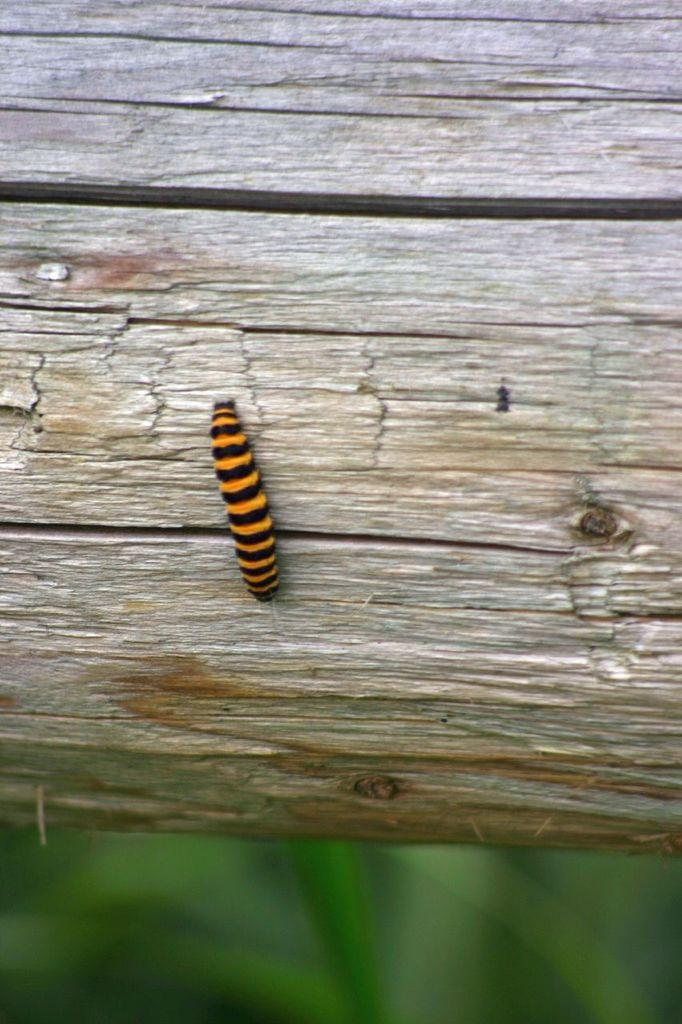Who is the main subject in the image? There is a skipper in the image. What is the skipper standing on? The skipper is on a wooden piece. Can you describe the foreground of the image? The foreground of the image is blurred. Is the skipper sleeping in the image? No, the skipper is not sleeping in the image; they are standing on a wooden piece. 